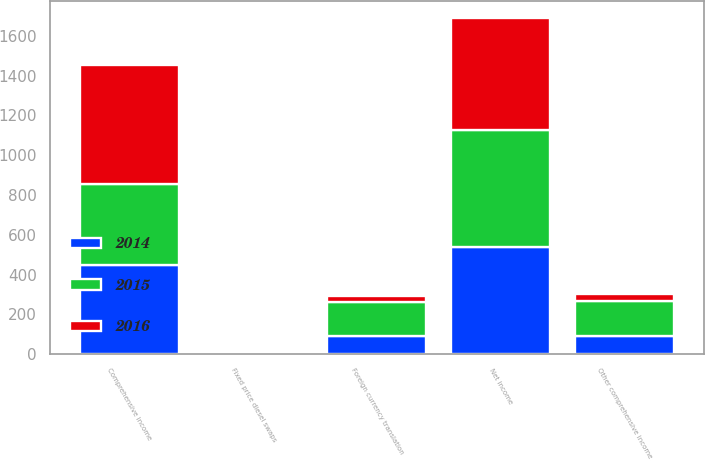<chart> <loc_0><loc_0><loc_500><loc_500><stacked_bar_chart><ecel><fcel>Net income<fcel>Foreign currency translation<fcel>Fixed price diesel swaps<fcel>Other comprehensive income<fcel>Comprehensive income<nl><fcel>2016<fcel>566<fcel>28<fcel>4<fcel>32<fcel>598<nl><fcel>2015<fcel>585<fcel>174<fcel>2<fcel>176<fcel>409<nl><fcel>2014<fcel>540<fcel>90<fcel>3<fcel>93<fcel>447<nl></chart> 